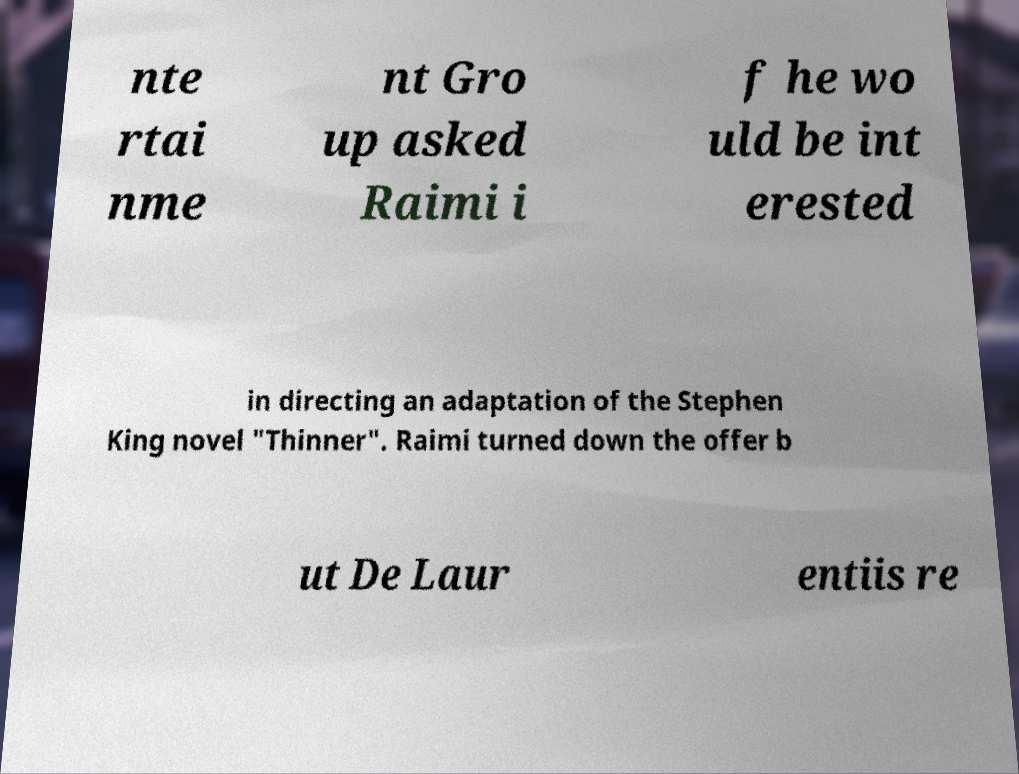I need the written content from this picture converted into text. Can you do that? nte rtai nme nt Gro up asked Raimi i f he wo uld be int erested in directing an adaptation of the Stephen King novel "Thinner". Raimi turned down the offer b ut De Laur entiis re 